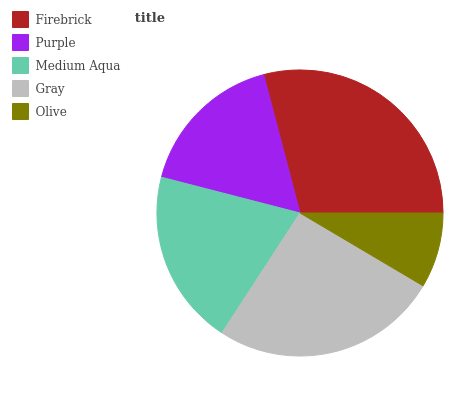Is Olive the minimum?
Answer yes or no. Yes. Is Firebrick the maximum?
Answer yes or no. Yes. Is Purple the minimum?
Answer yes or no. No. Is Purple the maximum?
Answer yes or no. No. Is Firebrick greater than Purple?
Answer yes or no. Yes. Is Purple less than Firebrick?
Answer yes or no. Yes. Is Purple greater than Firebrick?
Answer yes or no. No. Is Firebrick less than Purple?
Answer yes or no. No. Is Medium Aqua the high median?
Answer yes or no. Yes. Is Medium Aqua the low median?
Answer yes or no. Yes. Is Purple the high median?
Answer yes or no. No. Is Olive the low median?
Answer yes or no. No. 